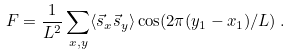<formula> <loc_0><loc_0><loc_500><loc_500>F = \frac { 1 } { L ^ { 2 } } \sum _ { x , y } \langle \vec { s } _ { x } \vec { s } _ { y } \rangle \cos ( 2 \pi ( y _ { 1 } - x _ { 1 } ) / L ) \, .</formula> 